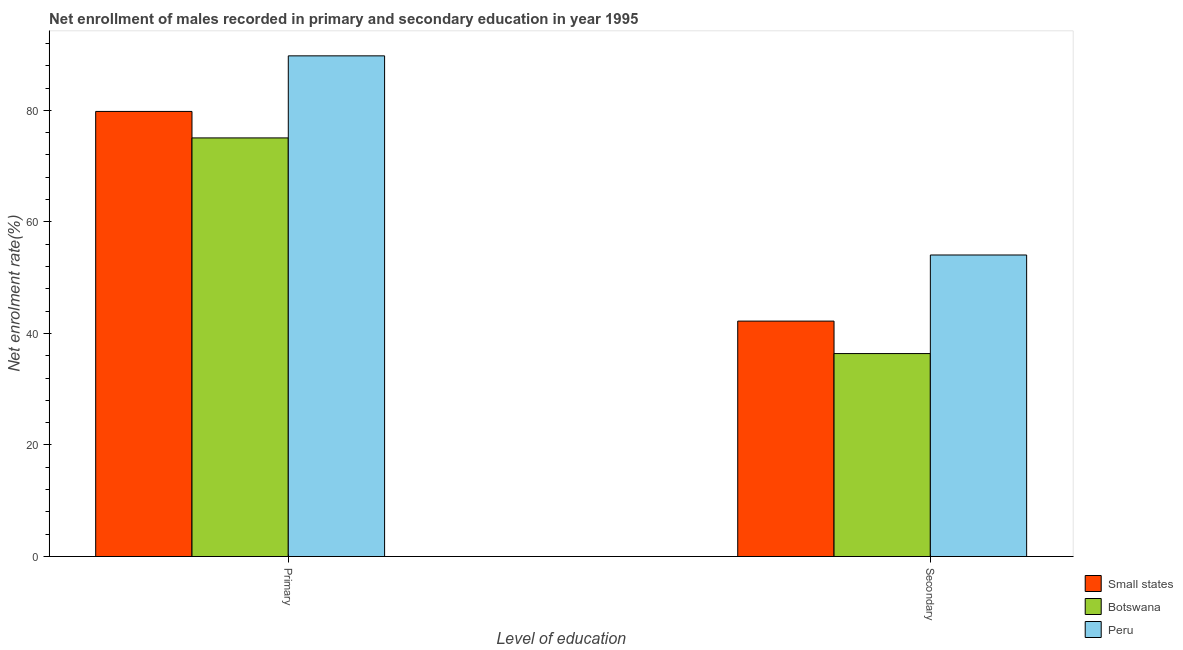How many groups of bars are there?
Offer a terse response. 2. Are the number of bars per tick equal to the number of legend labels?
Your answer should be very brief. Yes. Are the number of bars on each tick of the X-axis equal?
Keep it short and to the point. Yes. How many bars are there on the 1st tick from the left?
Your response must be concise. 3. What is the label of the 2nd group of bars from the left?
Ensure brevity in your answer.  Secondary. What is the enrollment rate in secondary education in Botswana?
Your response must be concise. 36.39. Across all countries, what is the maximum enrollment rate in primary education?
Your answer should be very brief. 89.77. Across all countries, what is the minimum enrollment rate in secondary education?
Your answer should be compact. 36.39. In which country was the enrollment rate in primary education maximum?
Offer a terse response. Peru. In which country was the enrollment rate in primary education minimum?
Provide a short and direct response. Botswana. What is the total enrollment rate in secondary education in the graph?
Provide a succinct answer. 132.67. What is the difference between the enrollment rate in secondary education in Peru and that in Botswana?
Give a very brief answer. 17.68. What is the difference between the enrollment rate in primary education in Peru and the enrollment rate in secondary education in Small states?
Offer a very short reply. 47.56. What is the average enrollment rate in primary education per country?
Your answer should be very brief. 81.55. What is the difference between the enrollment rate in secondary education and enrollment rate in primary education in Small states?
Ensure brevity in your answer.  -37.6. What is the ratio of the enrollment rate in primary education in Peru to that in Botswana?
Make the answer very short. 1.2. Is the enrollment rate in secondary education in Small states less than that in Botswana?
Make the answer very short. No. In how many countries, is the enrollment rate in secondary education greater than the average enrollment rate in secondary education taken over all countries?
Provide a short and direct response. 1. What does the 2nd bar from the left in Secondary represents?
Your answer should be very brief. Botswana. What does the 1st bar from the right in Secondary represents?
Provide a succinct answer. Peru. How many bars are there?
Your response must be concise. 6. What is the difference between two consecutive major ticks on the Y-axis?
Provide a short and direct response. 20. Does the graph contain grids?
Offer a terse response. No. Where does the legend appear in the graph?
Your answer should be compact. Bottom right. How many legend labels are there?
Provide a short and direct response. 3. How are the legend labels stacked?
Give a very brief answer. Vertical. What is the title of the graph?
Keep it short and to the point. Net enrollment of males recorded in primary and secondary education in year 1995. What is the label or title of the X-axis?
Provide a succinct answer. Level of education. What is the label or title of the Y-axis?
Make the answer very short. Net enrolment rate(%). What is the Net enrolment rate(%) in Small states in Primary?
Your response must be concise. 79.81. What is the Net enrolment rate(%) in Botswana in Primary?
Offer a very short reply. 75.06. What is the Net enrolment rate(%) in Peru in Primary?
Give a very brief answer. 89.77. What is the Net enrolment rate(%) in Small states in Secondary?
Make the answer very short. 42.21. What is the Net enrolment rate(%) in Botswana in Secondary?
Your answer should be compact. 36.39. What is the Net enrolment rate(%) of Peru in Secondary?
Ensure brevity in your answer.  54.07. Across all Level of education, what is the maximum Net enrolment rate(%) of Small states?
Make the answer very short. 79.81. Across all Level of education, what is the maximum Net enrolment rate(%) in Botswana?
Your answer should be very brief. 75.06. Across all Level of education, what is the maximum Net enrolment rate(%) of Peru?
Your answer should be compact. 89.77. Across all Level of education, what is the minimum Net enrolment rate(%) of Small states?
Your answer should be compact. 42.21. Across all Level of education, what is the minimum Net enrolment rate(%) in Botswana?
Make the answer very short. 36.39. Across all Level of education, what is the minimum Net enrolment rate(%) in Peru?
Make the answer very short. 54.07. What is the total Net enrolment rate(%) in Small states in the graph?
Ensure brevity in your answer.  122.02. What is the total Net enrolment rate(%) in Botswana in the graph?
Your response must be concise. 111.45. What is the total Net enrolment rate(%) of Peru in the graph?
Your response must be concise. 143.84. What is the difference between the Net enrolment rate(%) of Small states in Primary and that in Secondary?
Provide a succinct answer. 37.6. What is the difference between the Net enrolment rate(%) in Botswana in Primary and that in Secondary?
Ensure brevity in your answer.  38.67. What is the difference between the Net enrolment rate(%) in Peru in Primary and that in Secondary?
Ensure brevity in your answer.  35.7. What is the difference between the Net enrolment rate(%) of Small states in Primary and the Net enrolment rate(%) of Botswana in Secondary?
Your answer should be very brief. 43.42. What is the difference between the Net enrolment rate(%) in Small states in Primary and the Net enrolment rate(%) in Peru in Secondary?
Keep it short and to the point. 25.74. What is the difference between the Net enrolment rate(%) in Botswana in Primary and the Net enrolment rate(%) in Peru in Secondary?
Your answer should be compact. 20.99. What is the average Net enrolment rate(%) in Small states per Level of education?
Provide a succinct answer. 61.01. What is the average Net enrolment rate(%) of Botswana per Level of education?
Offer a terse response. 55.72. What is the average Net enrolment rate(%) of Peru per Level of education?
Keep it short and to the point. 71.92. What is the difference between the Net enrolment rate(%) in Small states and Net enrolment rate(%) in Botswana in Primary?
Keep it short and to the point. 4.75. What is the difference between the Net enrolment rate(%) of Small states and Net enrolment rate(%) of Peru in Primary?
Keep it short and to the point. -9.96. What is the difference between the Net enrolment rate(%) in Botswana and Net enrolment rate(%) in Peru in Primary?
Your answer should be very brief. -14.71. What is the difference between the Net enrolment rate(%) of Small states and Net enrolment rate(%) of Botswana in Secondary?
Offer a terse response. 5.82. What is the difference between the Net enrolment rate(%) of Small states and Net enrolment rate(%) of Peru in Secondary?
Provide a succinct answer. -11.86. What is the difference between the Net enrolment rate(%) of Botswana and Net enrolment rate(%) of Peru in Secondary?
Your answer should be very brief. -17.68. What is the ratio of the Net enrolment rate(%) of Small states in Primary to that in Secondary?
Offer a terse response. 1.89. What is the ratio of the Net enrolment rate(%) of Botswana in Primary to that in Secondary?
Your response must be concise. 2.06. What is the ratio of the Net enrolment rate(%) in Peru in Primary to that in Secondary?
Make the answer very short. 1.66. What is the difference between the highest and the second highest Net enrolment rate(%) of Small states?
Offer a very short reply. 37.6. What is the difference between the highest and the second highest Net enrolment rate(%) in Botswana?
Your answer should be very brief. 38.67. What is the difference between the highest and the second highest Net enrolment rate(%) in Peru?
Give a very brief answer. 35.7. What is the difference between the highest and the lowest Net enrolment rate(%) of Small states?
Provide a succinct answer. 37.6. What is the difference between the highest and the lowest Net enrolment rate(%) of Botswana?
Make the answer very short. 38.67. What is the difference between the highest and the lowest Net enrolment rate(%) in Peru?
Keep it short and to the point. 35.7. 